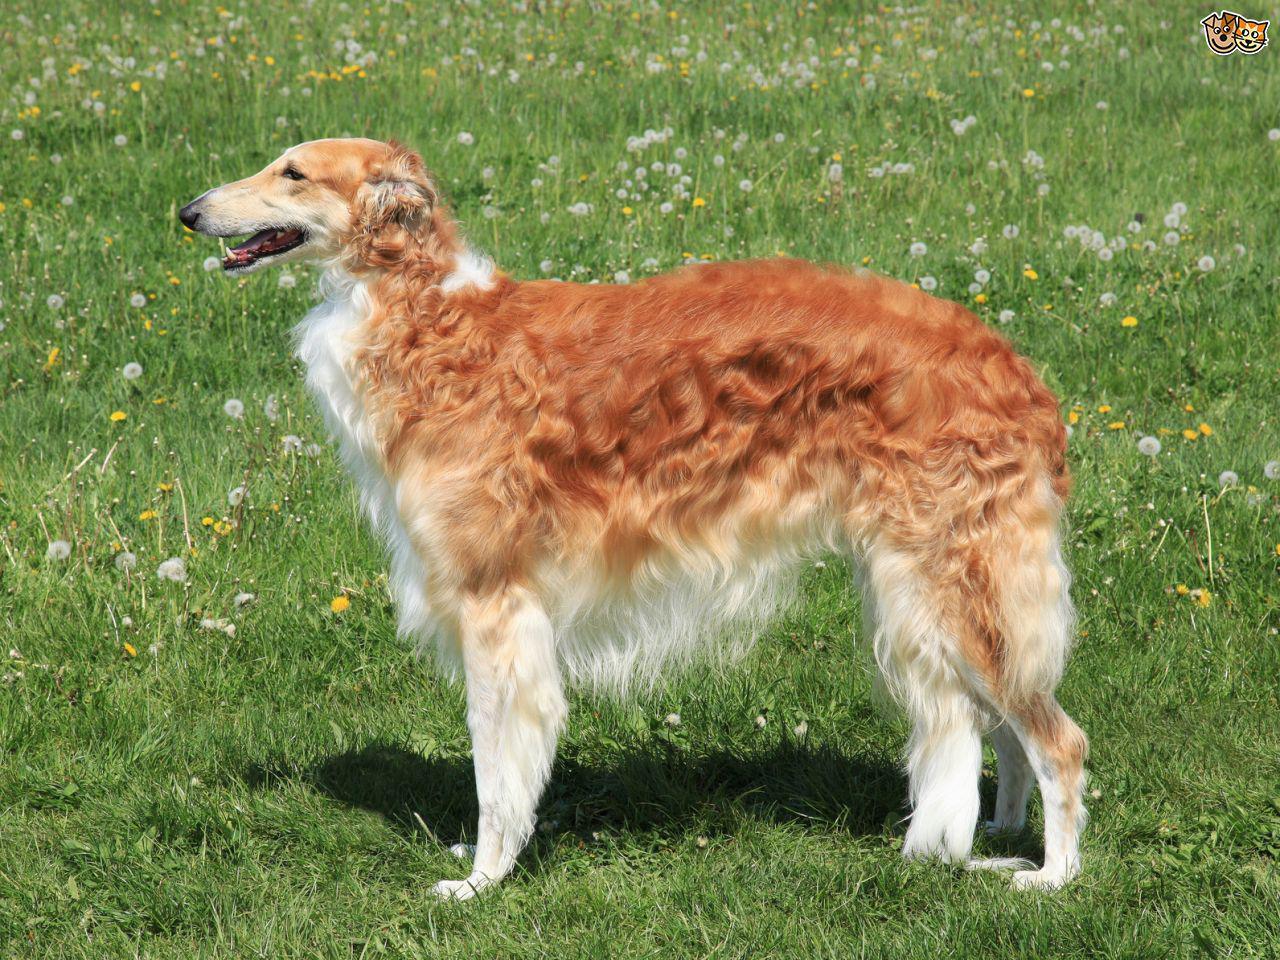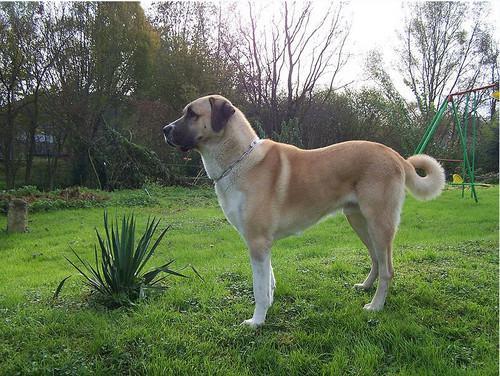The first image is the image on the left, the second image is the image on the right. For the images shown, is this caption "The left image shows one reddish-orange and white dog in full profile, facing left." true? Answer yes or no. Yes. 